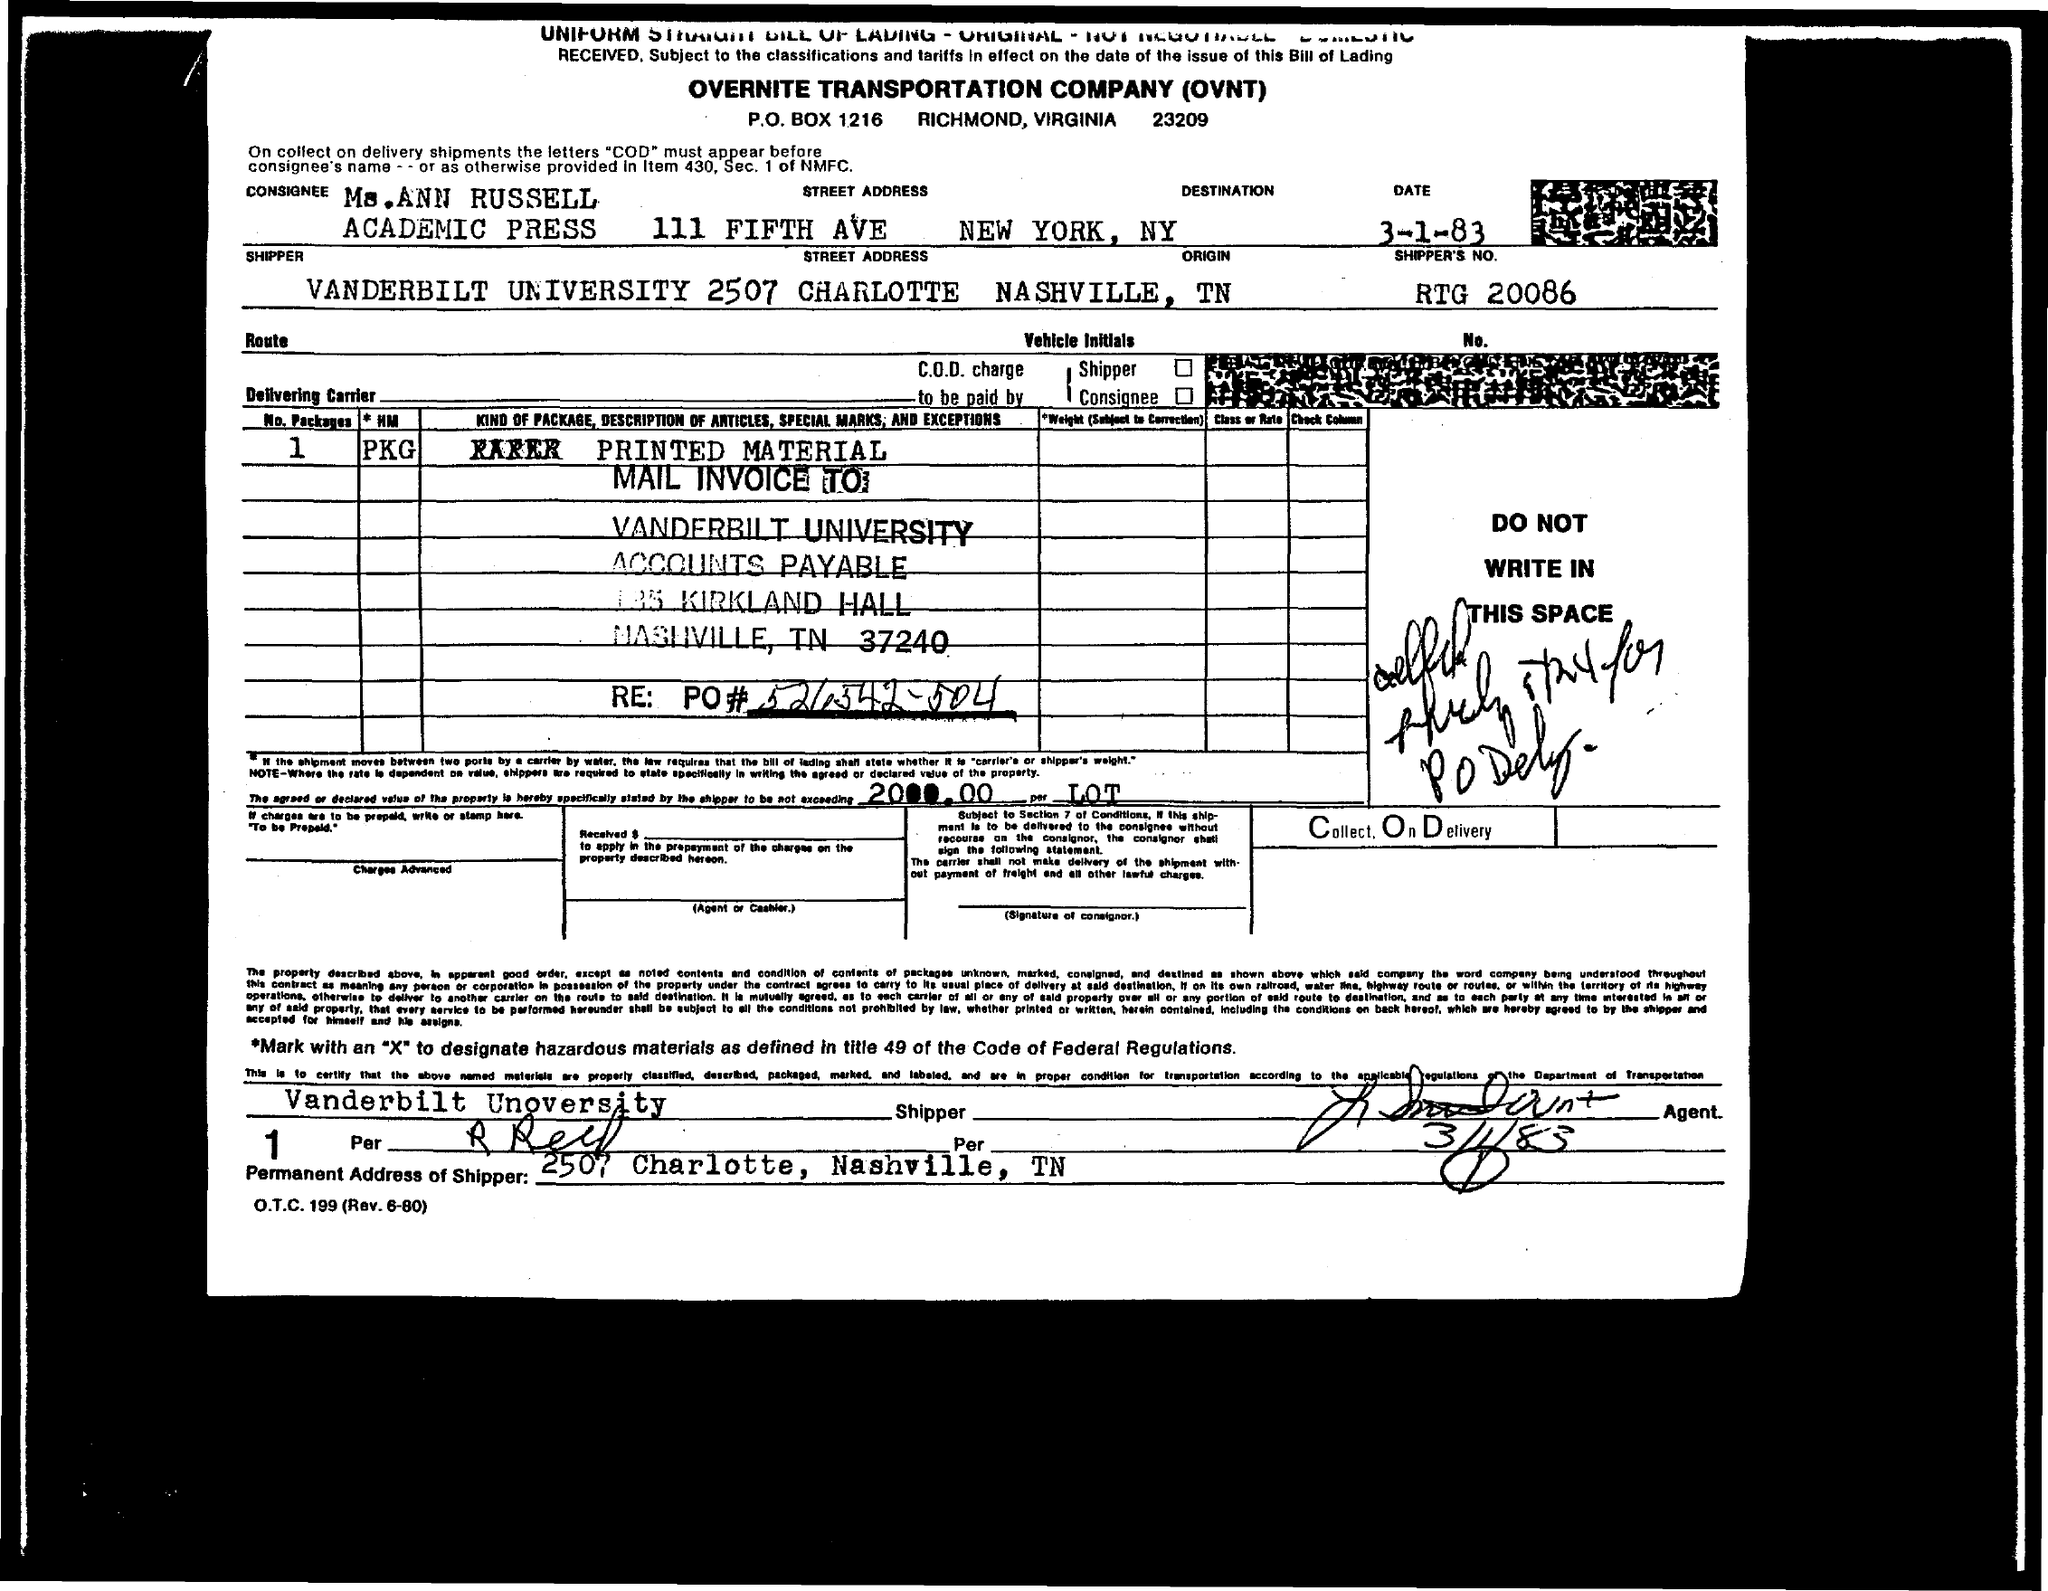What is the P.O.BOX Number ?
Provide a short and direct response. 1216. What is the Fullform of OVNT ?
Provide a succinct answer. OVERNITE TRANSPORTATION COMPANY. 